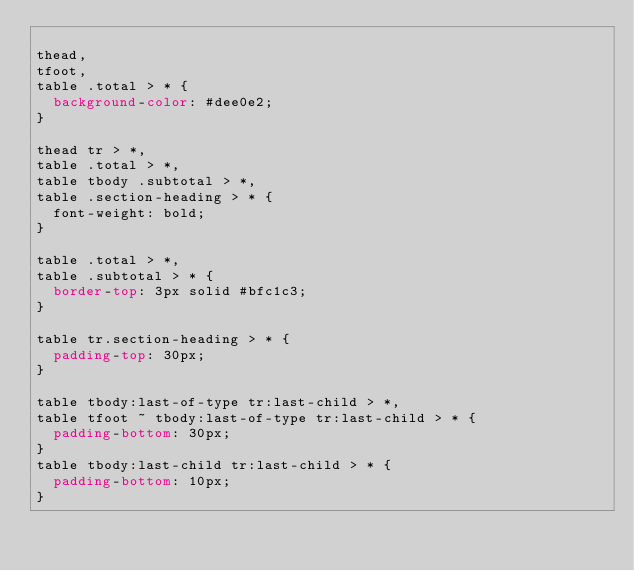<code> <loc_0><loc_0><loc_500><loc_500><_CSS_>
thead,
tfoot,
table .total > * {
  background-color: #dee0e2;
}

thead tr > *,
table .total > *,
table tbody .subtotal > *,
table .section-heading > * {
  font-weight: bold;
}

table .total > *,
table .subtotal > * {
  border-top: 3px solid #bfc1c3;
}

table tr.section-heading > * {
  padding-top: 30px;
}

table tbody:last-of-type tr:last-child > *,
table tfoot ~ tbody:last-of-type tr:last-child > * {
  padding-bottom: 30px;
}
table tbody:last-child tr:last-child > * {
  padding-bottom: 10px;
}
</code> 